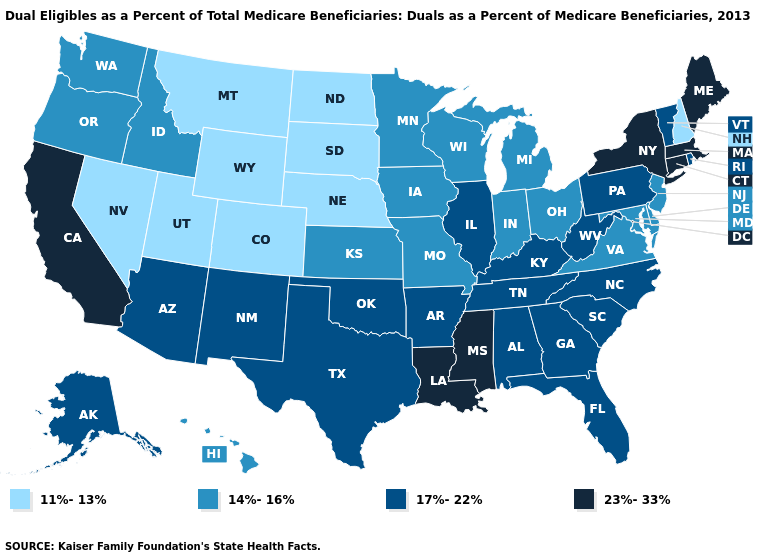Does North Carolina have a lower value than California?
Answer briefly. Yes. What is the value of Indiana?
Be succinct. 14%-16%. Among the states that border Kansas , which have the lowest value?
Be succinct. Colorado, Nebraska. Name the states that have a value in the range 17%-22%?
Keep it brief. Alabama, Alaska, Arizona, Arkansas, Florida, Georgia, Illinois, Kentucky, New Mexico, North Carolina, Oklahoma, Pennsylvania, Rhode Island, South Carolina, Tennessee, Texas, Vermont, West Virginia. What is the highest value in the Northeast ?
Keep it brief. 23%-33%. What is the lowest value in the MidWest?
Answer briefly. 11%-13%. Does New Hampshire have a lower value than Missouri?
Answer briefly. Yes. Which states have the highest value in the USA?
Give a very brief answer. California, Connecticut, Louisiana, Maine, Massachusetts, Mississippi, New York. Does North Carolina have the highest value in the USA?
Give a very brief answer. No. Among the states that border Kansas , which have the lowest value?
Quick response, please. Colorado, Nebraska. Does Oklahoma have the same value as South Carolina?
Short answer required. Yes. What is the highest value in the USA?
Give a very brief answer. 23%-33%. Which states hav the highest value in the MidWest?
Write a very short answer. Illinois. Does Delaware have a higher value than Utah?
Write a very short answer. Yes. Name the states that have a value in the range 14%-16%?
Keep it brief. Delaware, Hawaii, Idaho, Indiana, Iowa, Kansas, Maryland, Michigan, Minnesota, Missouri, New Jersey, Ohio, Oregon, Virginia, Washington, Wisconsin. 